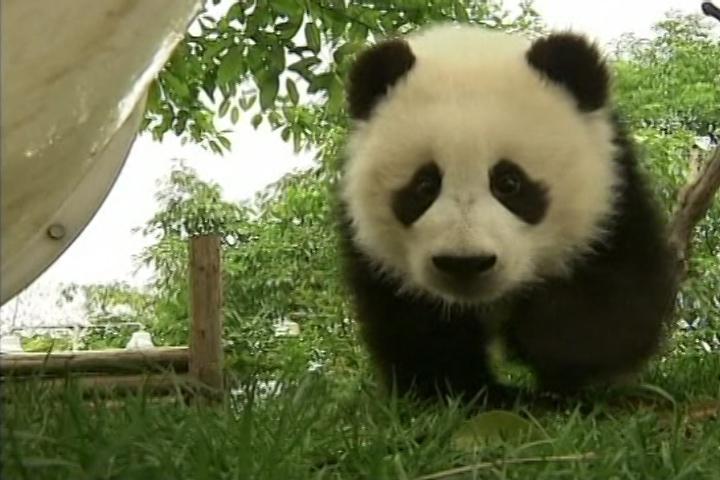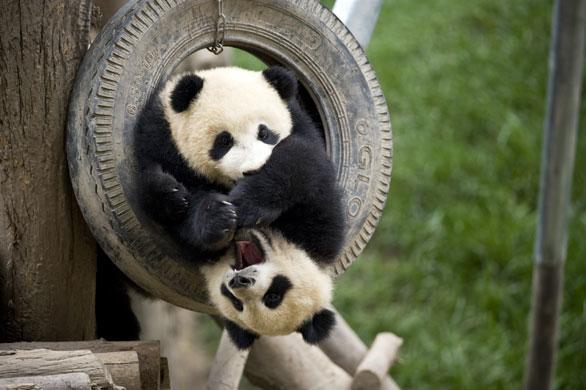The first image is the image on the left, the second image is the image on the right. Examine the images to the left and right. Is the description "One image shows at least one panda on top of bright yellow plastic playground equipment." accurate? Answer yes or no. No. The first image is the image on the left, the second image is the image on the right. Assess this claim about the two images: "The right image contains exactly two pandas.". Correct or not? Answer yes or no. Yes. 